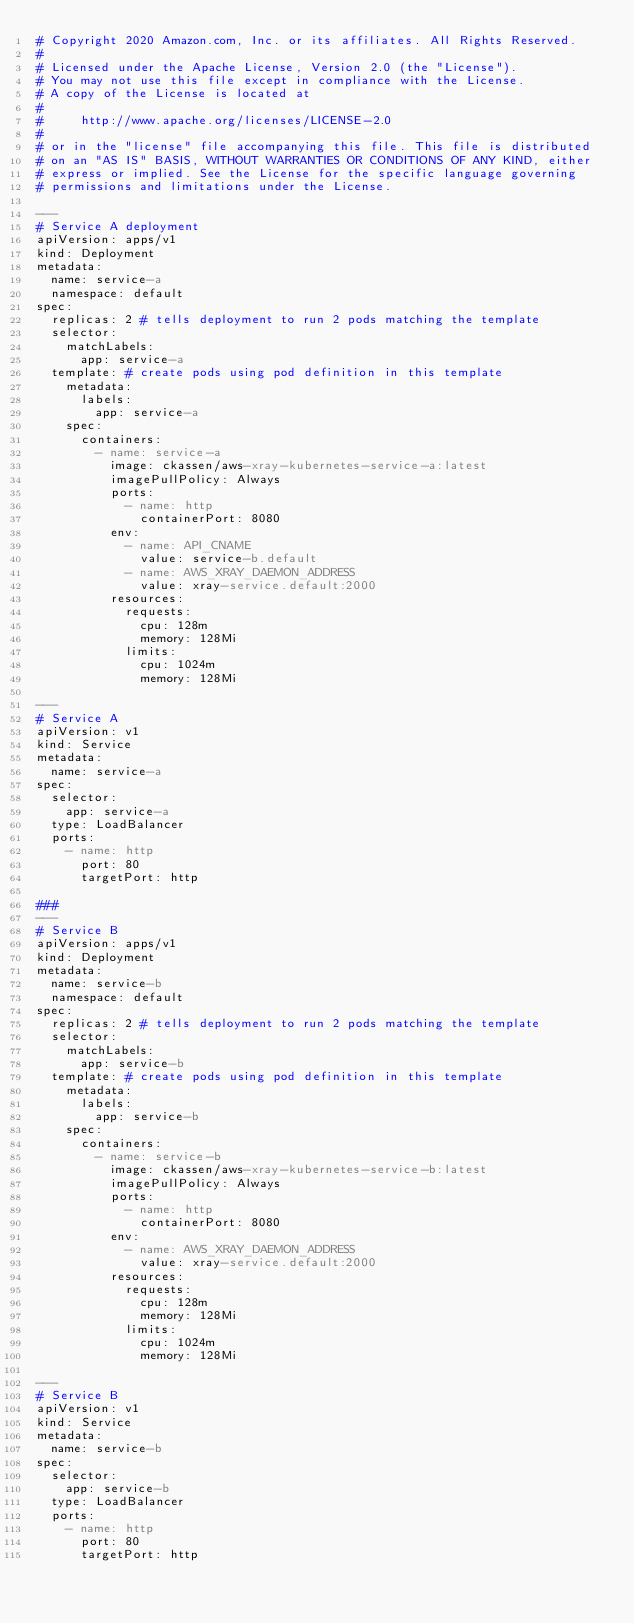<code> <loc_0><loc_0><loc_500><loc_500><_YAML_># Copyright 2020 Amazon.com, Inc. or its affiliates. All Rights Reserved.
#
# Licensed under the Apache License, Version 2.0 (the "License").
# You may not use this file except in compliance with the License.
# A copy of the License is located at
#
#     http://www.apache.org/licenses/LICENSE-2.0
#
# or in the "license" file accompanying this file. This file is distributed
# on an "AS IS" BASIS, WITHOUT WARRANTIES OR CONDITIONS OF ANY KIND, either
# express or implied. See the License for the specific language governing
# permissions and limitations under the License.

---
# Service A deployment
apiVersion: apps/v1
kind: Deployment
metadata:
  name: service-a
  namespace: default
spec:
  replicas: 2 # tells deployment to run 2 pods matching the template
  selector:
    matchLabels:
      app: service-a
  template: # create pods using pod definition in this template
    metadata:
      labels:
        app: service-a
    spec:
      containers:
        - name: service-a
          image: ckassen/aws-xray-kubernetes-service-a:latest
          imagePullPolicy: Always
          ports:
            - name: http
              containerPort: 8080
          env:
            - name: API_CNAME
              value: service-b.default
            - name: AWS_XRAY_DAEMON_ADDRESS
              value: xray-service.default:2000
          resources:
            requests:
              cpu: 128m
              memory: 128Mi
            limits:
              cpu: 1024m
              memory: 128Mi

---
# Service A
apiVersion: v1
kind: Service
metadata:
  name: service-a
spec:
  selector:
    app: service-a
  type: LoadBalancer
  ports:
    - name: http
      port: 80
      targetPort: http

###
---
# Service B
apiVersion: apps/v1
kind: Deployment
metadata:
  name: service-b
  namespace: default
spec:
  replicas: 2 # tells deployment to run 2 pods matching the template
  selector:
    matchLabels:
      app: service-b
  template: # create pods using pod definition in this template
    metadata:
      labels:
        app: service-b
    spec:
      containers:
        - name: service-b
          image: ckassen/aws-xray-kubernetes-service-b:latest
          imagePullPolicy: Always
          ports:
            - name: http
              containerPort: 8080
          env:
            - name: AWS_XRAY_DAEMON_ADDRESS
              value: xray-service.default:2000
          resources:
            requests:
              cpu: 128m
              memory: 128Mi
            limits:
              cpu: 1024m
              memory: 128Mi

---
# Service B
apiVersion: v1
kind: Service
metadata:
  name: service-b
spec:
  selector:
    app: service-b
  type: LoadBalancer
  ports:
    - name: http
      port: 80
      targetPort: http
</code> 